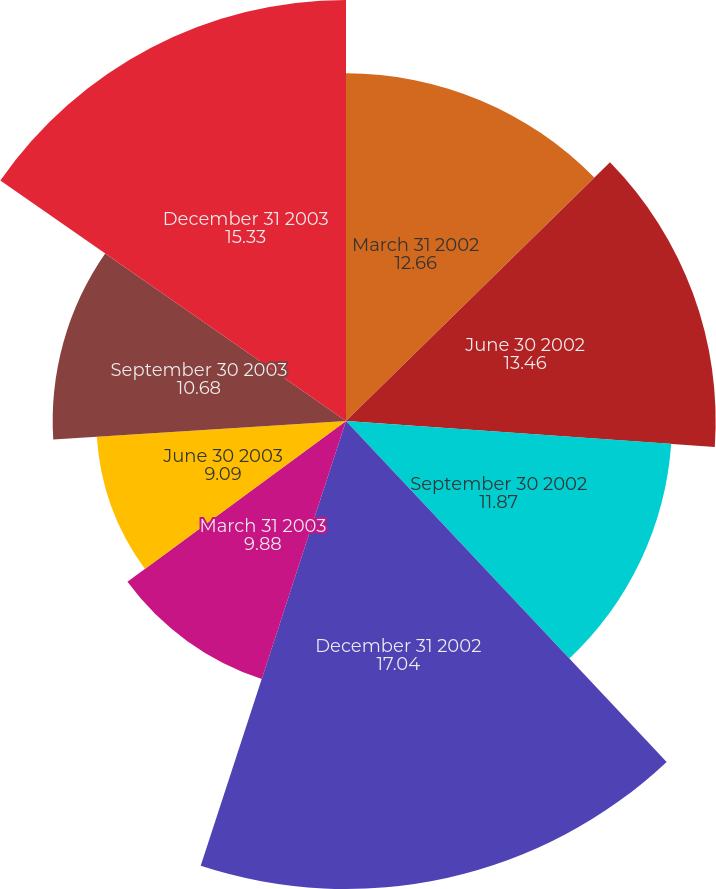Convert chart to OTSL. <chart><loc_0><loc_0><loc_500><loc_500><pie_chart><fcel>March 31 2002<fcel>June 30 2002<fcel>September 30 2002<fcel>December 31 2002<fcel>March 31 2003<fcel>June 30 2003<fcel>September 30 2003<fcel>December 31 2003<nl><fcel>12.66%<fcel>13.46%<fcel>11.87%<fcel>17.04%<fcel>9.88%<fcel>9.09%<fcel>10.68%<fcel>15.33%<nl></chart> 